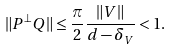Convert formula to latex. <formula><loc_0><loc_0><loc_500><loc_500>\| P ^ { \perp } Q \| \leq \frac { \pi } { 2 } \frac { \| V \| } { d - \delta _ { V } } < 1 .</formula> 